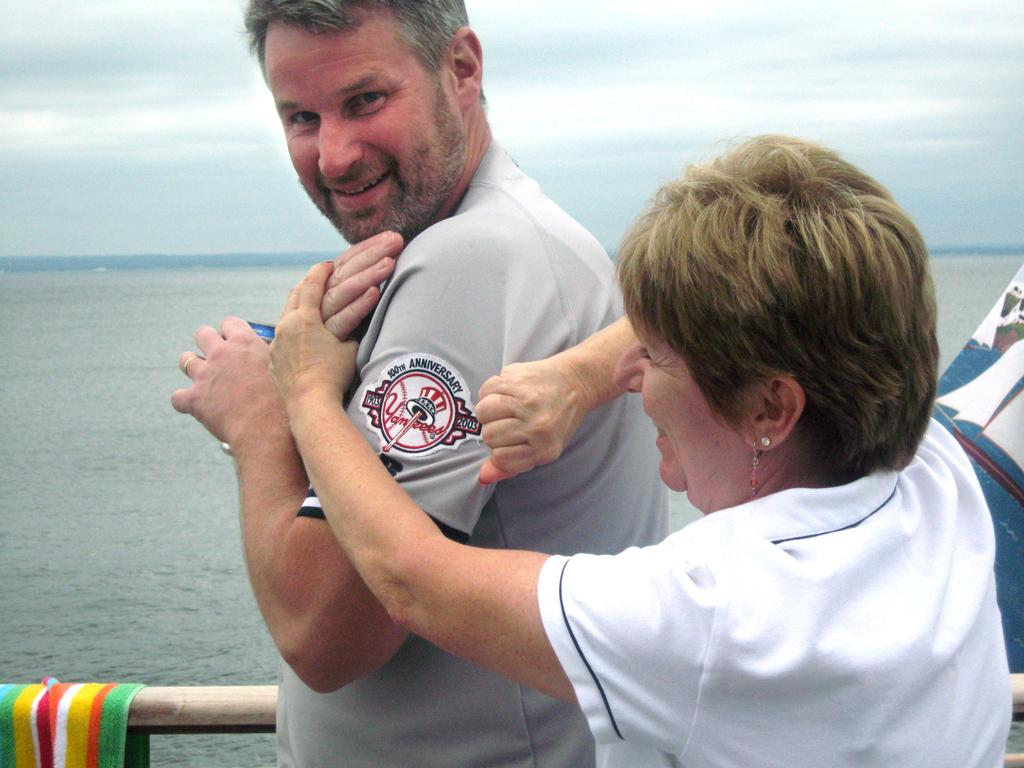<image>
Provide a brief description of the given image. A woman is showing a 100th Anniversary  Yankees patch on a man's arm 